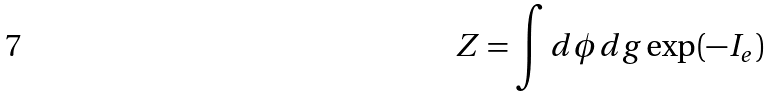<formula> <loc_0><loc_0><loc_500><loc_500>Z = \int d \phi d g \exp ( - I _ { e } )</formula> 